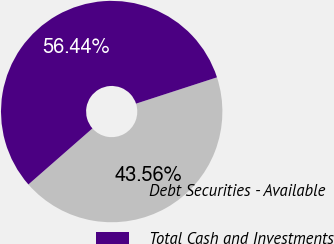Convert chart to OTSL. <chart><loc_0><loc_0><loc_500><loc_500><pie_chart><fcel>Debt Securities - Available<fcel>Total Cash and Investments<nl><fcel>43.56%<fcel>56.44%<nl></chart> 